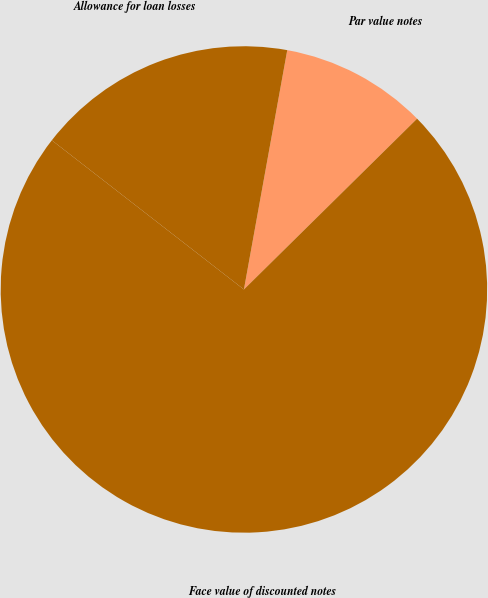Convert chart. <chart><loc_0><loc_0><loc_500><loc_500><pie_chart><fcel>Par value notes<fcel>Allowance for loan losses<fcel>Face value of discounted notes<nl><fcel>9.76%<fcel>17.34%<fcel>72.9%<nl></chart> 